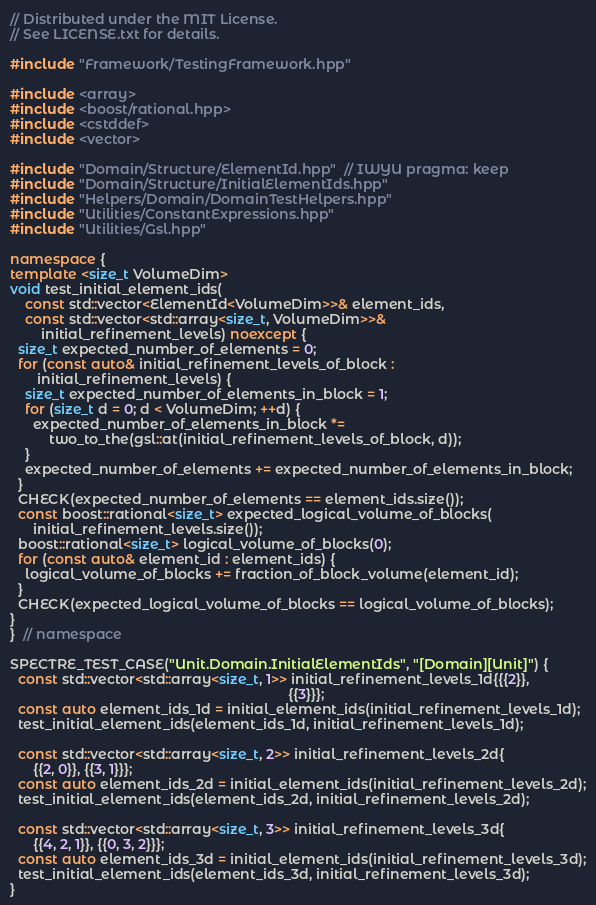Convert code to text. <code><loc_0><loc_0><loc_500><loc_500><_C++_>// Distributed under the MIT License.
// See LICENSE.txt for details.

#include "Framework/TestingFramework.hpp"

#include <array>
#include <boost/rational.hpp>
#include <cstddef>
#include <vector>

#include "Domain/Structure/ElementId.hpp"  // IWYU pragma: keep
#include "Domain/Structure/InitialElementIds.hpp"
#include "Helpers/Domain/DomainTestHelpers.hpp"
#include "Utilities/ConstantExpressions.hpp"
#include "Utilities/Gsl.hpp"

namespace {
template <size_t VolumeDim>
void test_initial_element_ids(
    const std::vector<ElementId<VolumeDim>>& element_ids,
    const std::vector<std::array<size_t, VolumeDim>>&
        initial_refinement_levels) noexcept {
  size_t expected_number_of_elements = 0;
  for (const auto& initial_refinement_levels_of_block :
       initial_refinement_levels) {
    size_t expected_number_of_elements_in_block = 1;
    for (size_t d = 0; d < VolumeDim; ++d) {
      expected_number_of_elements_in_block *=
          two_to_the(gsl::at(initial_refinement_levels_of_block, d));
    }
    expected_number_of_elements += expected_number_of_elements_in_block;
  }
  CHECK(expected_number_of_elements == element_ids.size());
  const boost::rational<size_t> expected_logical_volume_of_blocks(
      initial_refinement_levels.size());
  boost::rational<size_t> logical_volume_of_blocks(0);
  for (const auto& element_id : element_ids) {
    logical_volume_of_blocks += fraction_of_block_volume(element_id);
  }
  CHECK(expected_logical_volume_of_blocks == logical_volume_of_blocks);
}
}  // namespace

SPECTRE_TEST_CASE("Unit.Domain.InitialElementIds", "[Domain][Unit]") {
  const std::vector<std::array<size_t, 1>> initial_refinement_levels_1d{{{2}},
                                                                        {{3}}};
  const auto element_ids_1d = initial_element_ids(initial_refinement_levels_1d);
  test_initial_element_ids(element_ids_1d, initial_refinement_levels_1d);

  const std::vector<std::array<size_t, 2>> initial_refinement_levels_2d{
      {{2, 0}}, {{3, 1}}};
  const auto element_ids_2d = initial_element_ids(initial_refinement_levels_2d);
  test_initial_element_ids(element_ids_2d, initial_refinement_levels_2d);

  const std::vector<std::array<size_t, 3>> initial_refinement_levels_3d{
      {{4, 2, 1}}, {{0, 3, 2}}};
  const auto element_ids_3d = initial_element_ids(initial_refinement_levels_3d);
  test_initial_element_ids(element_ids_3d, initial_refinement_levels_3d);
}
</code> 